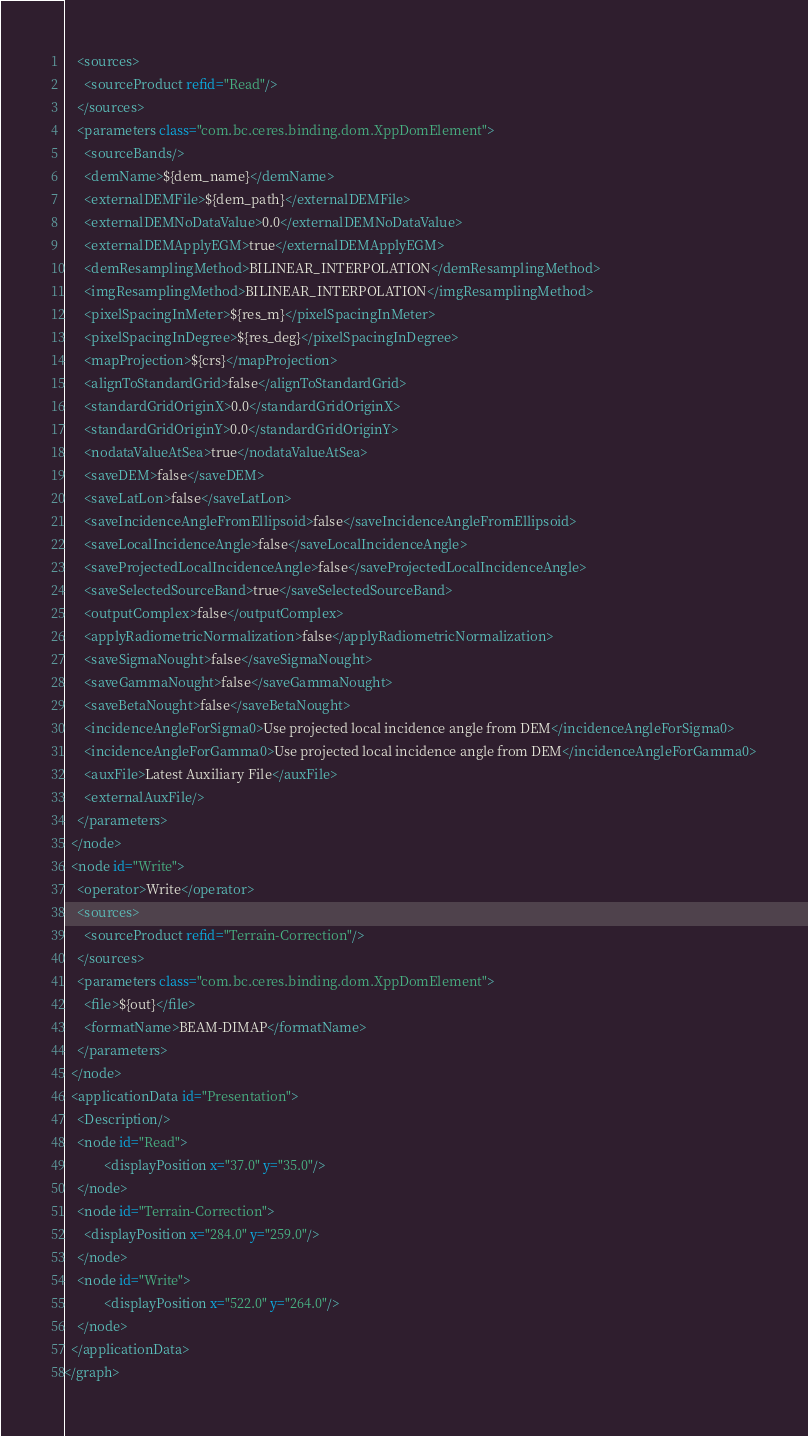Convert code to text. <code><loc_0><loc_0><loc_500><loc_500><_XML_>    <sources>
      <sourceProduct refid="Read"/>
    </sources>
    <parameters class="com.bc.ceres.binding.dom.XppDomElement">
      <sourceBands/>
      <demName>${dem_name}</demName>
      <externalDEMFile>${dem_path}</externalDEMFile>
      <externalDEMNoDataValue>0.0</externalDEMNoDataValue>
      <externalDEMApplyEGM>true</externalDEMApplyEGM>
      <demResamplingMethod>BILINEAR_INTERPOLATION</demResamplingMethod>
      <imgResamplingMethod>BILINEAR_INTERPOLATION</imgResamplingMethod>
      <pixelSpacingInMeter>${res_m}</pixelSpacingInMeter>
      <pixelSpacingInDegree>${res_deg}</pixelSpacingInDegree>
      <mapProjection>${crs}</mapProjection>
      <alignToStandardGrid>false</alignToStandardGrid>
      <standardGridOriginX>0.0</standardGridOriginX>
      <standardGridOriginY>0.0</standardGridOriginY>
      <nodataValueAtSea>true</nodataValueAtSea>
      <saveDEM>false</saveDEM>
      <saveLatLon>false</saveLatLon>
      <saveIncidenceAngleFromEllipsoid>false</saveIncidenceAngleFromEllipsoid>
      <saveLocalIncidenceAngle>false</saveLocalIncidenceAngle>
      <saveProjectedLocalIncidenceAngle>false</saveProjectedLocalIncidenceAngle>
      <saveSelectedSourceBand>true</saveSelectedSourceBand>
      <outputComplex>false</outputComplex>
      <applyRadiometricNormalization>false</applyRadiometricNormalization>
      <saveSigmaNought>false</saveSigmaNought>
      <saveGammaNought>false</saveGammaNought>
      <saveBetaNought>false</saveBetaNought>
      <incidenceAngleForSigma0>Use projected local incidence angle from DEM</incidenceAngleForSigma0>
      <incidenceAngleForGamma0>Use projected local incidence angle from DEM</incidenceAngleForGamma0>
      <auxFile>Latest Auxiliary File</auxFile>
      <externalAuxFile/>
    </parameters>
  </node>
  <node id="Write">
    <operator>Write</operator>
    <sources>
      <sourceProduct refid="Terrain-Correction"/>
    </sources>
    <parameters class="com.bc.ceres.binding.dom.XppDomElement">
      <file>${out}</file>
      <formatName>BEAM-DIMAP</formatName>
    </parameters>
  </node>
  <applicationData id="Presentation">
    <Description/>
    <node id="Read">
            <displayPosition x="37.0" y="35.0"/>
    </node>
    <node id="Terrain-Correction">
      <displayPosition x="284.0" y="259.0"/>
    </node>
    <node id="Write">
            <displayPosition x="522.0" y="264.0"/>
    </node>
  </applicationData>
</graph>
</code> 